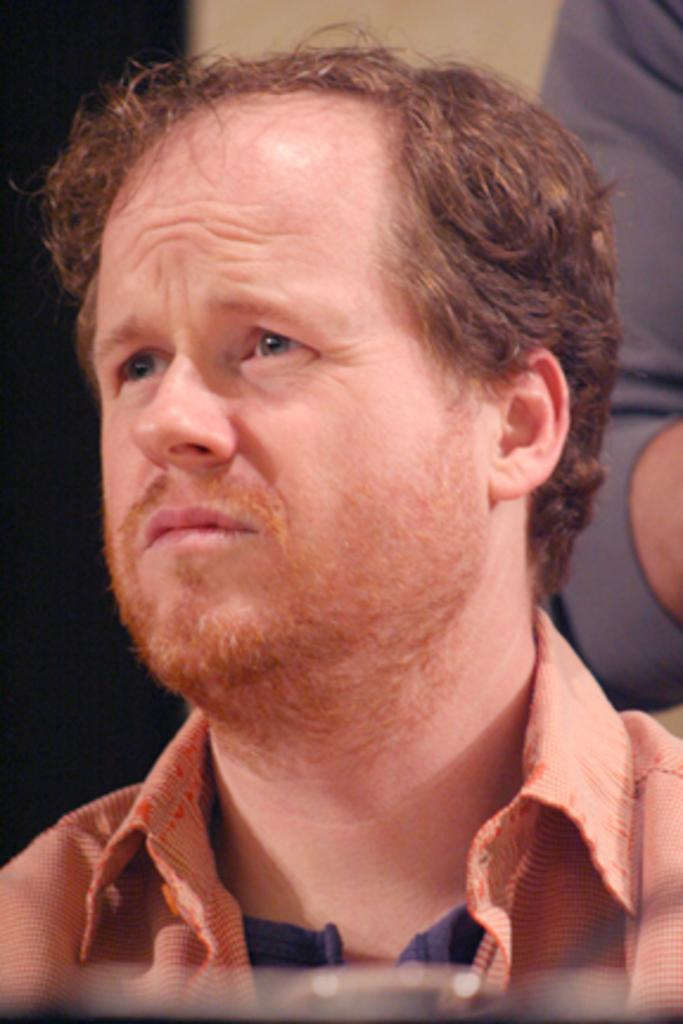How many people are in the image? There is one person in the image. Where is the person located in the image? The person is in the middle of the image. Can you see any body parts of another person in the image? Yes, a hand of a person is visible on the right side of the image. What type of glass is the person holding in the image? There is no glass present in the image. Can you see the person's brain in the image? No, the person's brain is not visible in the image. 